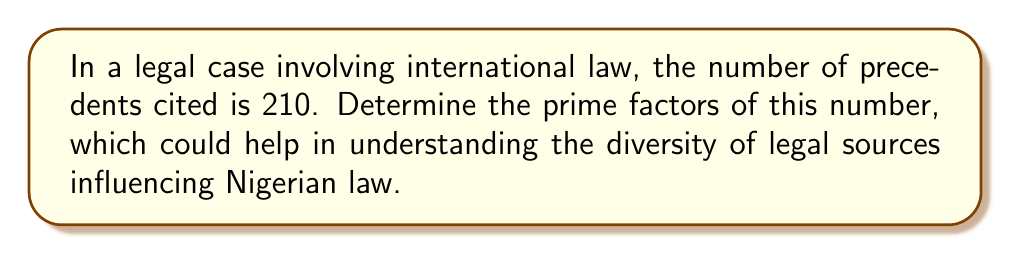Could you help me with this problem? To find the prime factors of 210, we'll use the process of prime factorization:

1) First, let's divide 210 by the smallest prime number that divides it evenly:

   $210 \div 2 = 105$

2) 105 is odd, so let's try the next prime number, 3:

   $105 \div 3 = 35$

3) 35 is also divisible by 5:

   $35 \div 5 = 7$

4) 7 is a prime number, so we stop here.

Therefore, we can write 210 as a product of its prime factors:

$$210 = 2 \times 3 \times 5 \times 7$$

Each of these factors (2, 3, 5, and 7) is a prime number.
Answer: $2 \times 3 \times 5 \times 7$ 